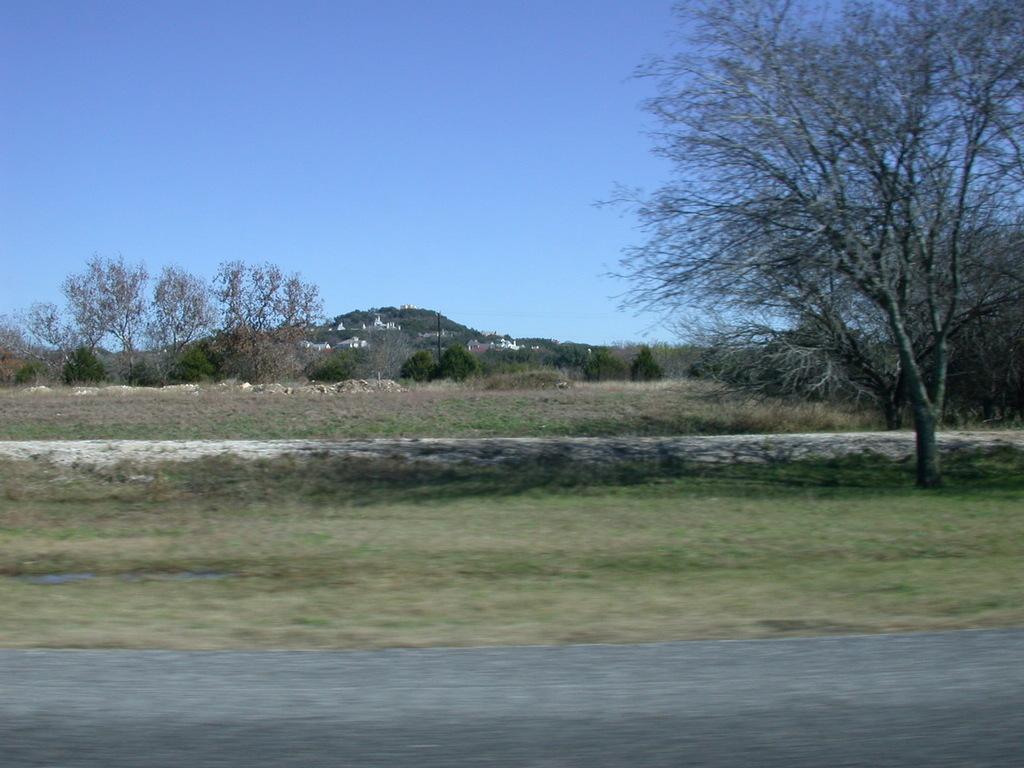Please provide a concise description of this image. In this image in front there is a road. In the background there are buildings, trees and sky. At the bottom of the image there is grass on the surface. 